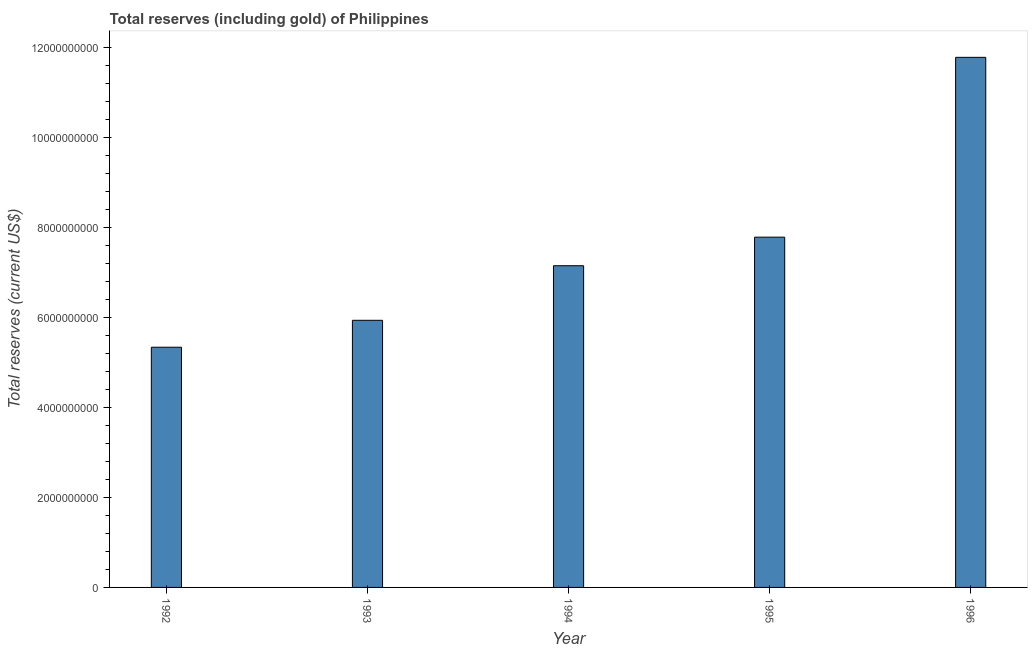What is the title of the graph?
Ensure brevity in your answer.  Total reserves (including gold) of Philippines. What is the label or title of the X-axis?
Ensure brevity in your answer.  Year. What is the label or title of the Y-axis?
Keep it short and to the point. Total reserves (current US$). What is the total reserves (including gold) in 1994?
Provide a short and direct response. 7.15e+09. Across all years, what is the maximum total reserves (including gold)?
Your answer should be compact. 1.18e+1. Across all years, what is the minimum total reserves (including gold)?
Keep it short and to the point. 5.34e+09. In which year was the total reserves (including gold) minimum?
Offer a terse response. 1992. What is the sum of the total reserves (including gold)?
Your answer should be very brief. 3.80e+1. What is the difference between the total reserves (including gold) in 1993 and 1995?
Keep it short and to the point. -1.85e+09. What is the average total reserves (including gold) per year?
Keep it short and to the point. 7.59e+09. What is the median total reserves (including gold)?
Make the answer very short. 7.15e+09. Do a majority of the years between 1993 and 1995 (inclusive) have total reserves (including gold) greater than 7600000000 US$?
Keep it short and to the point. No. What is the ratio of the total reserves (including gold) in 1992 to that in 1996?
Offer a terse response. 0.45. Is the total reserves (including gold) in 1992 less than that in 1994?
Offer a very short reply. Yes. What is the difference between the highest and the second highest total reserves (including gold)?
Offer a very short reply. 3.99e+09. What is the difference between the highest and the lowest total reserves (including gold)?
Your answer should be very brief. 6.44e+09. In how many years, is the total reserves (including gold) greater than the average total reserves (including gold) taken over all years?
Your response must be concise. 2. What is the difference between two consecutive major ticks on the Y-axis?
Ensure brevity in your answer.  2.00e+09. Are the values on the major ticks of Y-axis written in scientific E-notation?
Your answer should be compact. No. What is the Total reserves (current US$) in 1992?
Give a very brief answer. 5.34e+09. What is the Total reserves (current US$) of 1993?
Make the answer very short. 5.93e+09. What is the Total reserves (current US$) of 1994?
Ensure brevity in your answer.  7.15e+09. What is the Total reserves (current US$) of 1995?
Provide a short and direct response. 7.78e+09. What is the Total reserves (current US$) of 1996?
Make the answer very short. 1.18e+1. What is the difference between the Total reserves (current US$) in 1992 and 1993?
Make the answer very short. -5.98e+08. What is the difference between the Total reserves (current US$) in 1992 and 1994?
Your answer should be very brief. -1.81e+09. What is the difference between the Total reserves (current US$) in 1992 and 1995?
Ensure brevity in your answer.  -2.45e+09. What is the difference between the Total reserves (current US$) in 1992 and 1996?
Provide a succinct answer. -6.44e+09. What is the difference between the Total reserves (current US$) in 1993 and 1994?
Ensure brevity in your answer.  -1.21e+09. What is the difference between the Total reserves (current US$) in 1993 and 1995?
Make the answer very short. -1.85e+09. What is the difference between the Total reserves (current US$) in 1993 and 1996?
Your answer should be compact. -5.84e+09. What is the difference between the Total reserves (current US$) in 1994 and 1995?
Provide a short and direct response. -6.35e+08. What is the difference between the Total reserves (current US$) in 1994 and 1996?
Your answer should be very brief. -4.63e+09. What is the difference between the Total reserves (current US$) in 1995 and 1996?
Provide a succinct answer. -3.99e+09. What is the ratio of the Total reserves (current US$) in 1992 to that in 1993?
Ensure brevity in your answer.  0.9. What is the ratio of the Total reserves (current US$) in 1992 to that in 1994?
Your response must be concise. 0.75. What is the ratio of the Total reserves (current US$) in 1992 to that in 1995?
Your answer should be very brief. 0.69. What is the ratio of the Total reserves (current US$) in 1992 to that in 1996?
Give a very brief answer. 0.45. What is the ratio of the Total reserves (current US$) in 1993 to that in 1994?
Keep it short and to the point. 0.83. What is the ratio of the Total reserves (current US$) in 1993 to that in 1995?
Ensure brevity in your answer.  0.76. What is the ratio of the Total reserves (current US$) in 1993 to that in 1996?
Your response must be concise. 0.5. What is the ratio of the Total reserves (current US$) in 1994 to that in 1995?
Offer a very short reply. 0.92. What is the ratio of the Total reserves (current US$) in 1994 to that in 1996?
Offer a terse response. 0.61. What is the ratio of the Total reserves (current US$) in 1995 to that in 1996?
Your answer should be very brief. 0.66. 